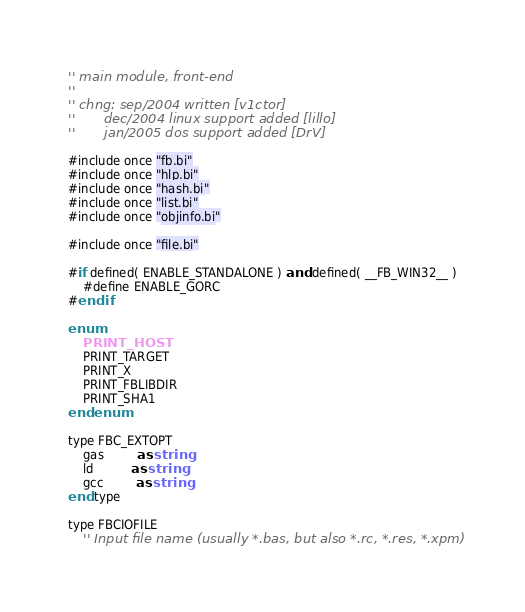Convert code to text. <code><loc_0><loc_0><loc_500><loc_500><_VisualBasic_>'' main module, front-end
''
'' chng: sep/2004 written [v1ctor]
''       dec/2004 linux support added [lillo]
''       jan/2005 dos support added [DrV]

#include once "fb.bi"
#include once "hlp.bi"
#include once "hash.bi"
#include once "list.bi"
#include once "objinfo.bi"

#include once "file.bi"

#if defined( ENABLE_STANDALONE ) and defined( __FB_WIN32__ )
	#define ENABLE_GORC
#endif

enum
	PRINT_HOST
	PRINT_TARGET
	PRINT_X
	PRINT_FBLIBDIR
	PRINT_SHA1
end enum

type FBC_EXTOPT
	gas         as string
	ld          as string
	gcc         as string
end type

type FBCIOFILE
	'' Input file name (usually *.bas, but also *.rc, *.res, *.xpm)</code> 